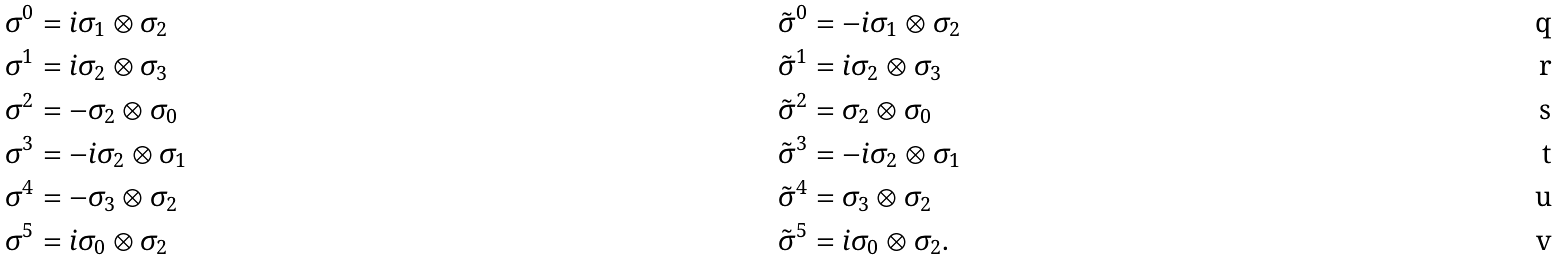Convert formula to latex. <formula><loc_0><loc_0><loc_500><loc_500>\sigma ^ { 0 } & = i \sigma _ { 1 } \otimes \sigma _ { 2 } & \tilde { \sigma } ^ { 0 } & = - i \sigma _ { 1 } \otimes \sigma _ { 2 } \\ \sigma ^ { 1 } & = i \sigma _ { 2 } \otimes \sigma _ { 3 } & \tilde { \sigma } ^ { 1 } & = i \sigma _ { 2 } \otimes \sigma _ { 3 } \\ \sigma ^ { 2 } & = - \sigma _ { 2 } \otimes \sigma _ { 0 } & \tilde { \sigma } ^ { 2 } & = \sigma _ { 2 } \otimes \sigma _ { 0 } \\ \sigma ^ { 3 } & = - i \sigma _ { 2 } \otimes \sigma _ { 1 } & \tilde { \sigma } ^ { 3 } & = - i \sigma _ { 2 } \otimes \sigma _ { 1 } \\ \sigma ^ { 4 } & = - \sigma _ { 3 } \otimes \sigma _ { 2 } & \tilde { \sigma } ^ { 4 } & = \sigma _ { 3 } \otimes \sigma _ { 2 } \\ \sigma ^ { 5 } & = i \sigma _ { 0 } \otimes \sigma _ { 2 } & \tilde { \sigma } ^ { 5 } & = i \sigma _ { 0 } \otimes \sigma _ { 2 } .</formula> 